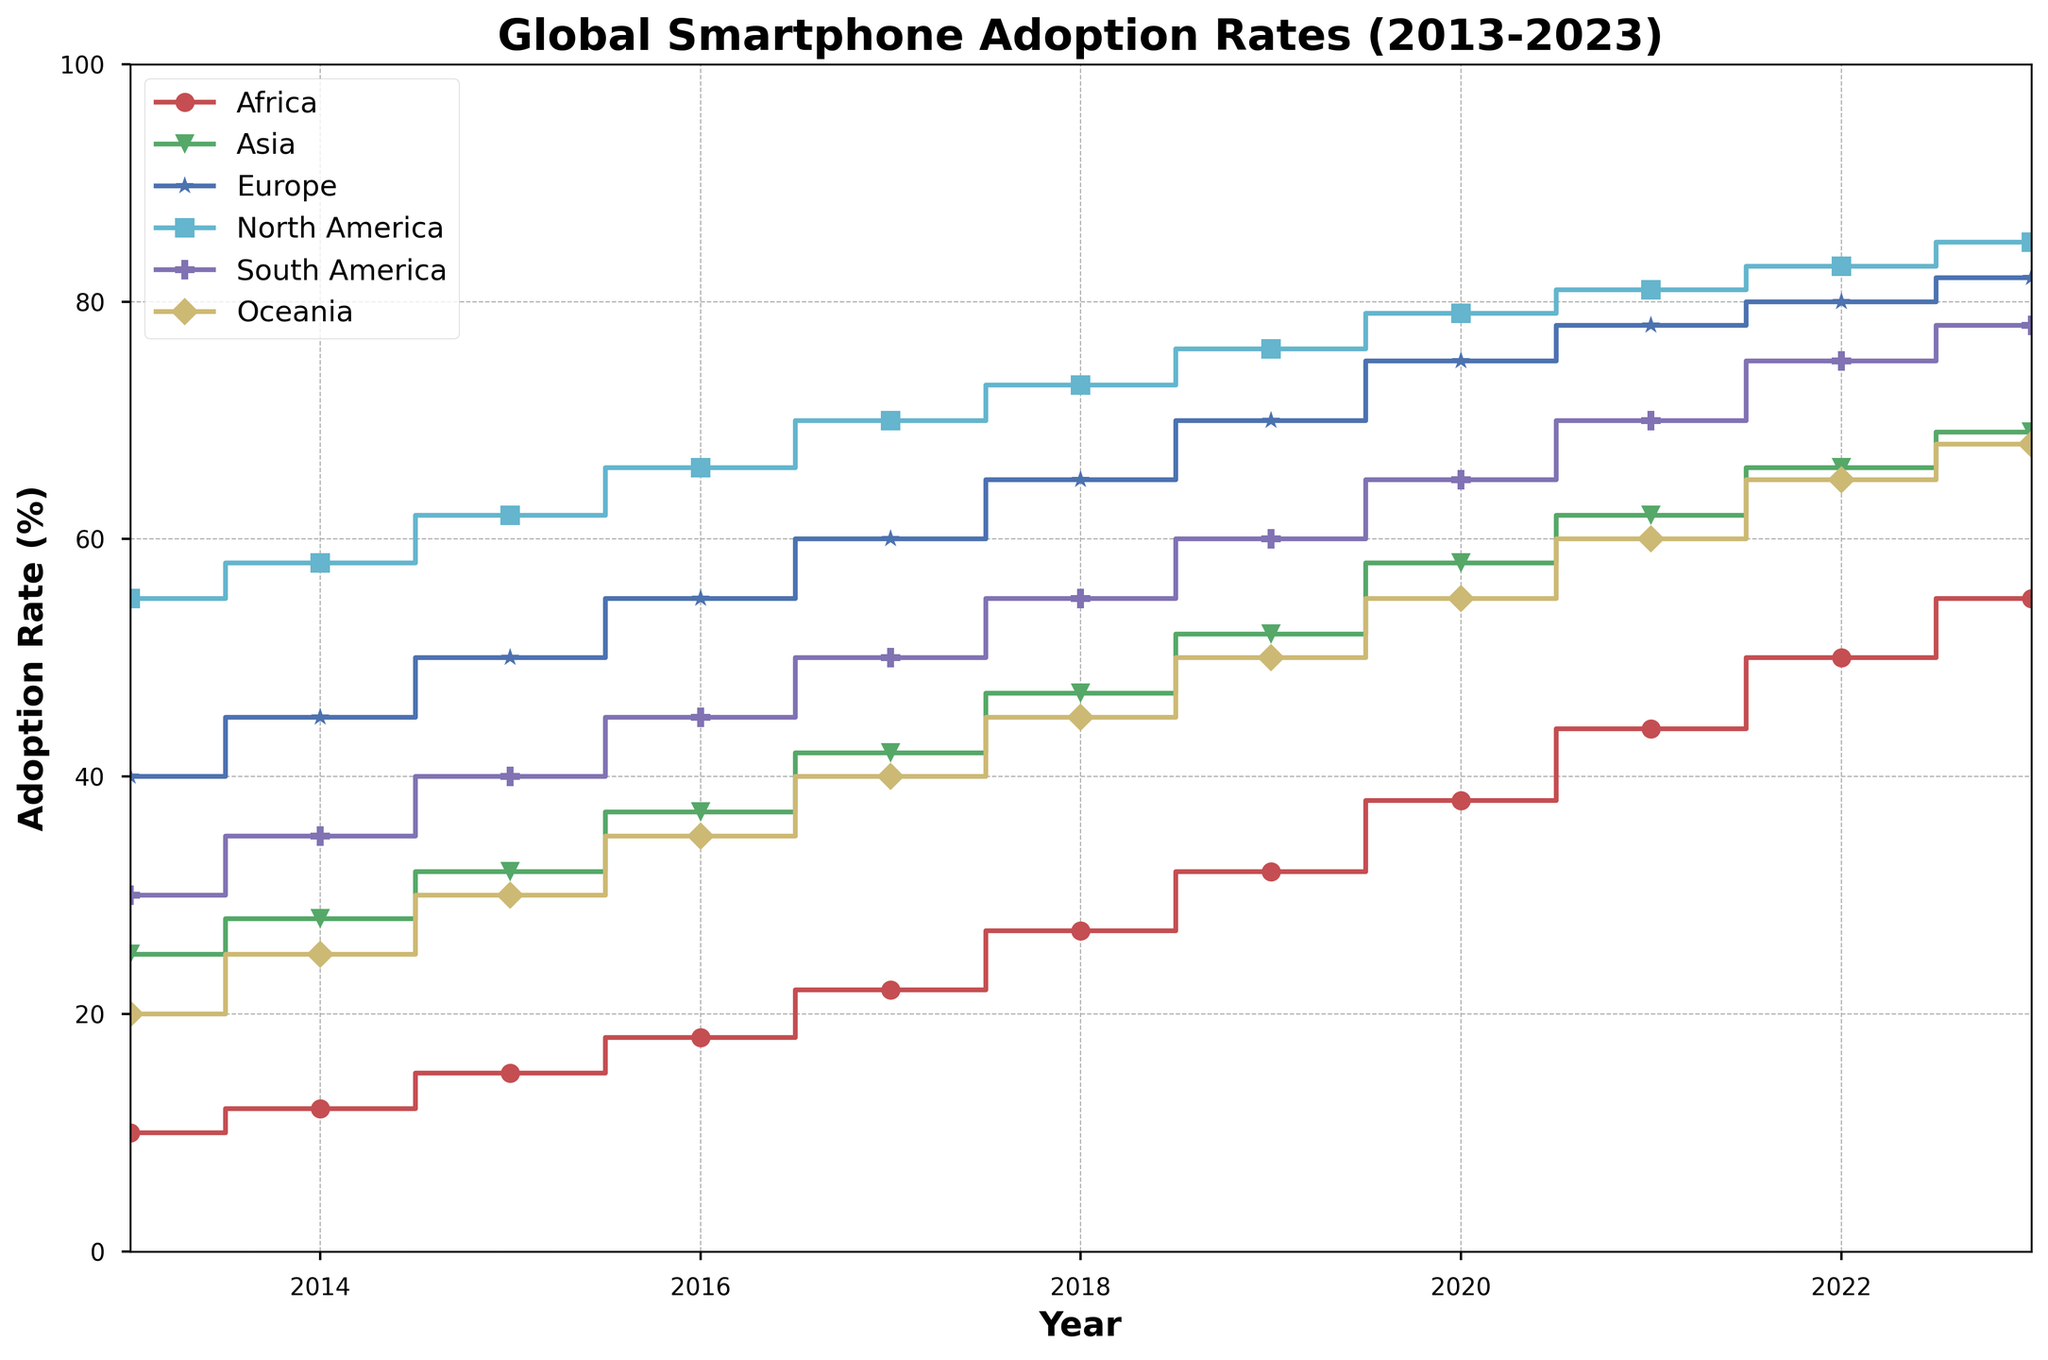Which region saw the highest increase in smartphone adoption rate from 2013 to 2023? Examine the starting and ending points of each region's line. Africa starts at 10% in 2013 and rises to 55% in 2023, giving an increase of 45%. Compare this with other regions and see Africa has the highest increase.
Answer: Africa What was the smartphone adoption rate in North America in 2017? Look at the point where North America's line intersects 2017 on the x-axis, the y-value is 70%.
Answer: 70% In what year did Oceania's smartphone adoption rate reach 50%? Locate the point on the Oceania line where the y-value touches 50%, which is 2019.
Answer: 2019 Which region has the least fluctuating growth in smartphone adoption rate over the given period? Examine the lines for smoothness and consistent growth. North America's line shows a very steady and smooth trend compared to other regions.
Answer: North America What is the average yearly increase in smartphone adoption rate for Asia from 2013 to 2023? Asia started at 25% in 2013 and reached 69% in 2023. The total increase is 69% - 25% = 44%. Over 10 years, the average yearly increase is 44% / 10 = 4.4%.
Answer: 4.4% Which two regions have the most similar adoption rates in 2023? Compare the endpoints of all lines in 2023. North America and Europe intersect closely at 85% and 82% respectively.
Answer: North America and Europe Which region shows the greatest decrease in smartphone adoption increase rate between 2020 and 2023? Determine the slope of each segment between these years. Africa goes from 38% to 55% (17%), Asia from 58% to 69% (11%), Europe from 75% to 82% (7%), North America 79% to 85% (6%), South America goes from 65% to 78% (13%), and Oceania from 55% to 68% (13%). The smallest increase, indicating the greatest decrease in rate, is Europe with 7%.
Answer: Europe Which year's adoption rate in South America was equal to the subsequent year’s adoption rate in Africa? Compare South America's line to find a year where its value matches the next year value of Africa. In 2021, South America is at 70%, which matches Africa's 70% in 2022.
Answer: 2021 By how much did the smartphone adoption rate in Oceania increase between 2016 and 2019? Oceania was at 35% in 2016 and increased to 50% in 2019. The difference is 50% - 35% = 15%.
Answer: 15% 